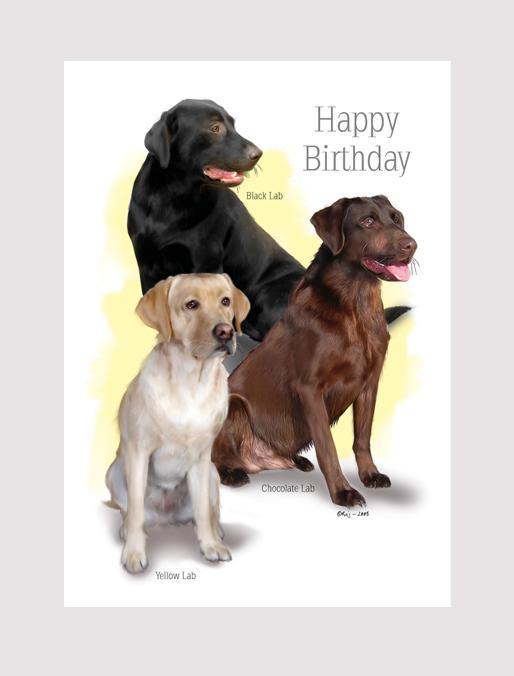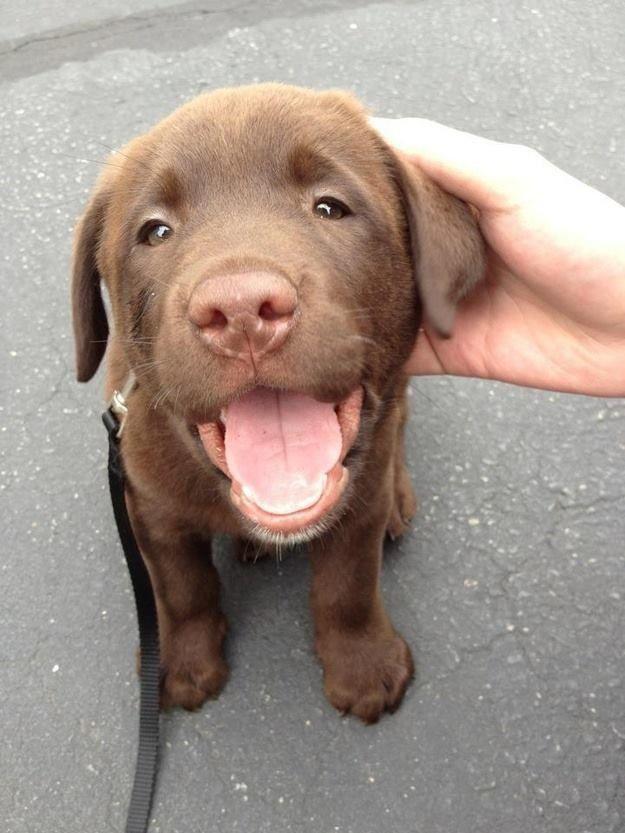The first image is the image on the left, the second image is the image on the right. Analyze the images presented: Is the assertion "There are exactly four dogs." valid? Answer yes or no. Yes. The first image is the image on the left, the second image is the image on the right. Evaluate the accuracy of this statement regarding the images: "There are exactly four dogs in total.". Is it true? Answer yes or no. Yes. 